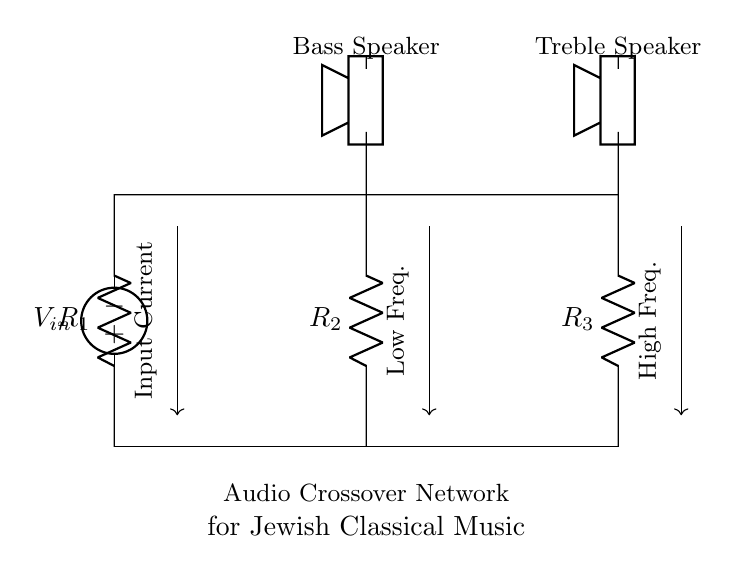What are the resistances in the circuit? The circuit contains three resistors labeled as R1, R2, and R3. These represent the resistances in the current divider network.
Answer: R1, R2, R3 What is the function of R2 in the circuit? R2 acts as a branch in the current divider network, allowing some current to flow towards the low-frequency output speaker, separating it from the high-frequency output.
Answer: Low-frequency division What is the input voltage labeled? The input voltage source is labeled as V_in, indicating the voltage supplied to the circuit for both frequency outputs.
Answer: V_in How many branches are there in the circuit? There are two branches in this current divider circuit, one for low frequencies and the other for high frequencies, facilitated by R2 and R3 respectively.
Answer: Two Which component connects to the treble speaker? The treble speaker is connected to the resistor R3 in the circuit, which directs high-frequency signals to the speaker.
Answer: R3 How does current divide between R2 and R3? The current divides according to the resistance values, where lower resistance gets more current, allowing for separation of low and high frequencies based on the resistors' values.
Answer: By resistance values 